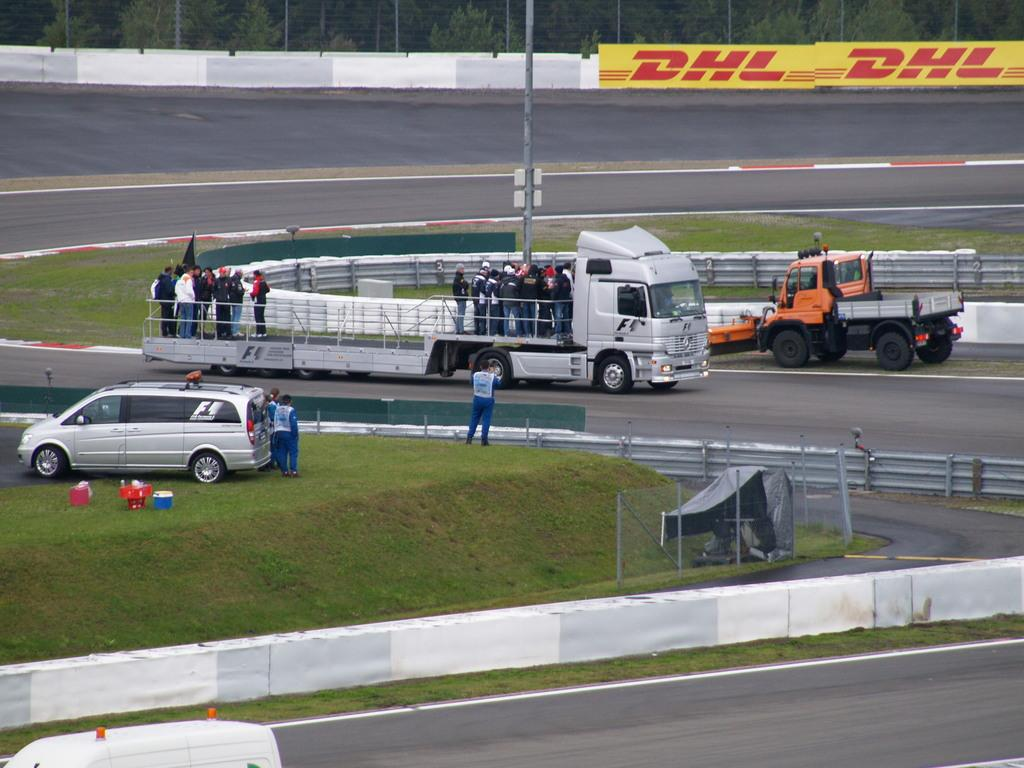What can be seen on the road in the image? There are vehicles on the road in the image. Who or what else is present in the image? There are people in the image. What is visible at the bottom of the image? There is a road visible at the bottom of the image. What can be seen in the background of the image? There is a pole, a fence, and trees in the background of the image. How does the fireman make a decision in the image? There is no fireman present in the image, so it is not possible to answer this question. 